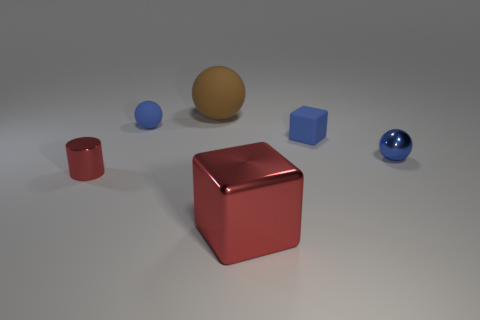What is the color of the tiny cube?
Your answer should be compact. Blue. How many other things are there of the same shape as the large red metallic object?
Offer a very short reply. 1. Is the number of blue things behind the blue metal ball the same as the number of objects in front of the tiny blue rubber block?
Your response must be concise. No. What is the large block made of?
Offer a very short reply. Metal. There is a big thing that is behind the red metallic cube; what is it made of?
Your answer should be compact. Rubber. Are there any other things that have the same material as the tiny block?
Offer a terse response. Yes. Is the number of large metallic cubes behind the small rubber block greater than the number of small blue matte cubes?
Give a very brief answer. No. There is a matte sphere to the right of the small blue rubber object left of the brown rubber thing; are there any blue cubes that are on the right side of it?
Offer a very short reply. Yes. Are there any tiny red cylinders to the right of the small blue block?
Offer a very short reply. No. What number of large shiny objects are the same color as the tiny cylinder?
Your answer should be very brief. 1. 